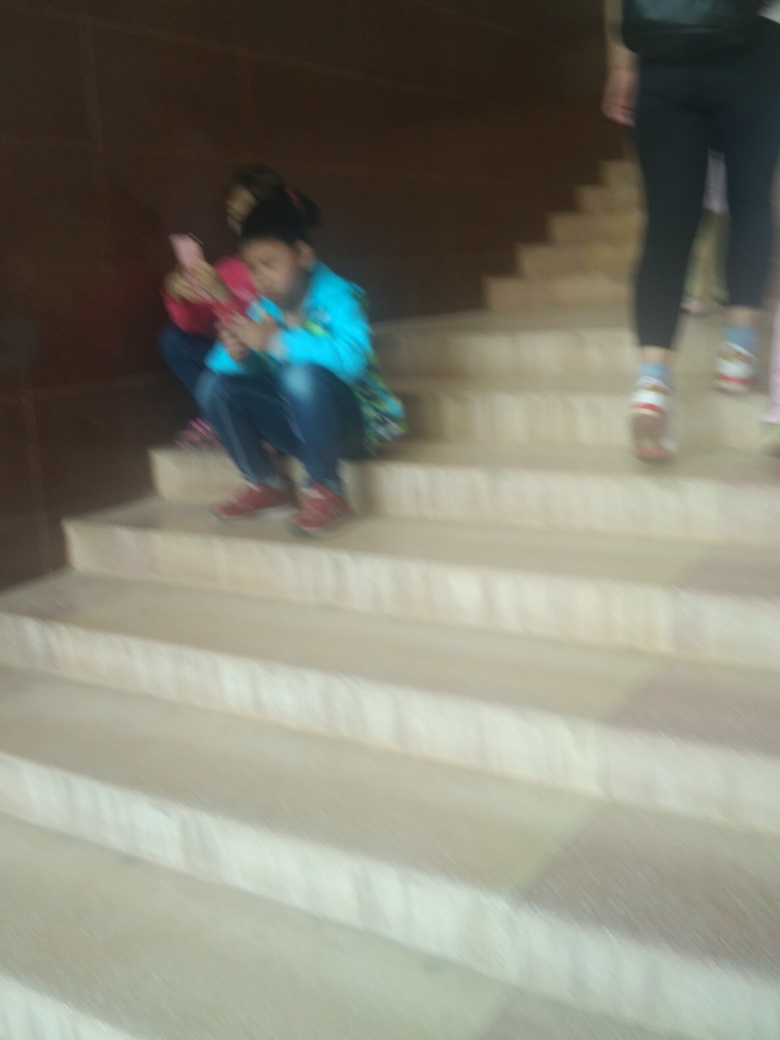What can we infer about the location based on the image? The location appears to be an indoor public space, characterized by heavy stonework and stairs, hinting it could be a section of a modern institution or public building. 